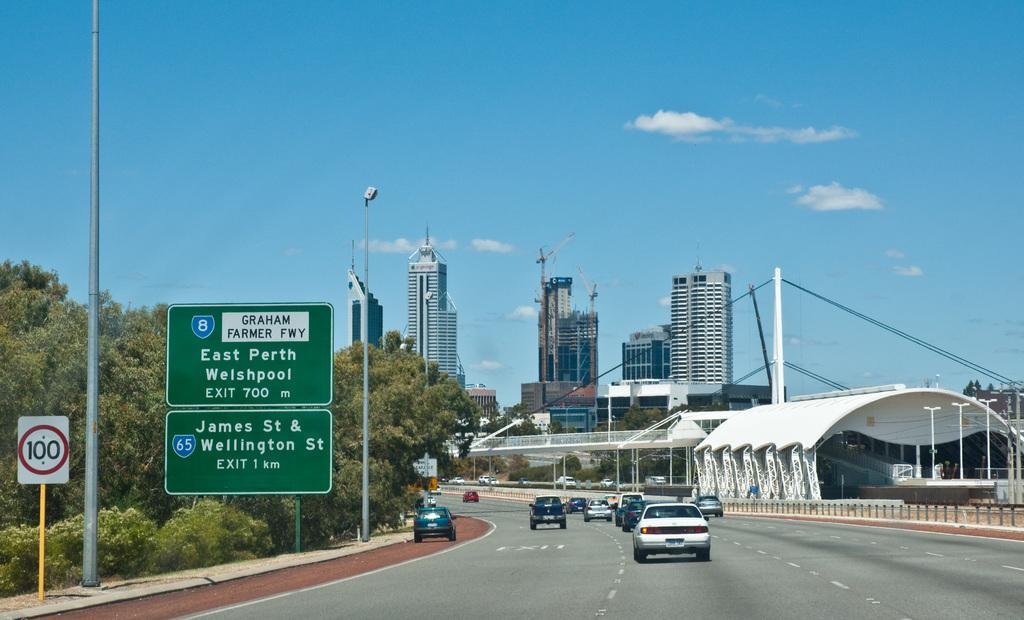<image>
Describe the image concisely. a picture with a road sign of east perth welshpool. 